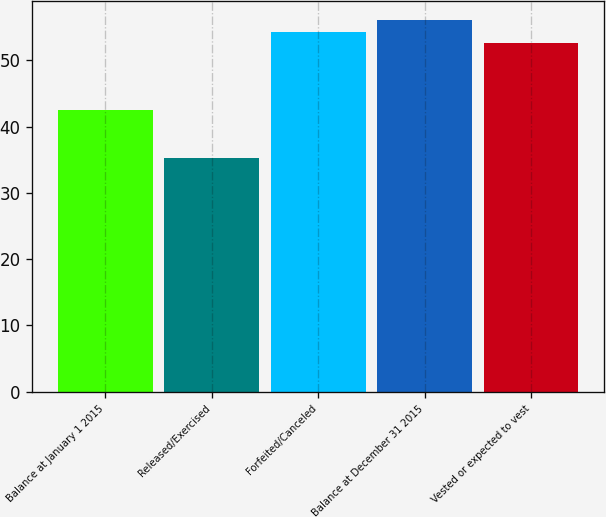Convert chart to OTSL. <chart><loc_0><loc_0><loc_500><loc_500><bar_chart><fcel>Balance at January 1 2015<fcel>Released/Exercised<fcel>Forfeited/Canceled<fcel>Balance at December 31 2015<fcel>Vested or expected to vest<nl><fcel>42.47<fcel>35.32<fcel>54.36<fcel>56.14<fcel>52.58<nl></chart> 